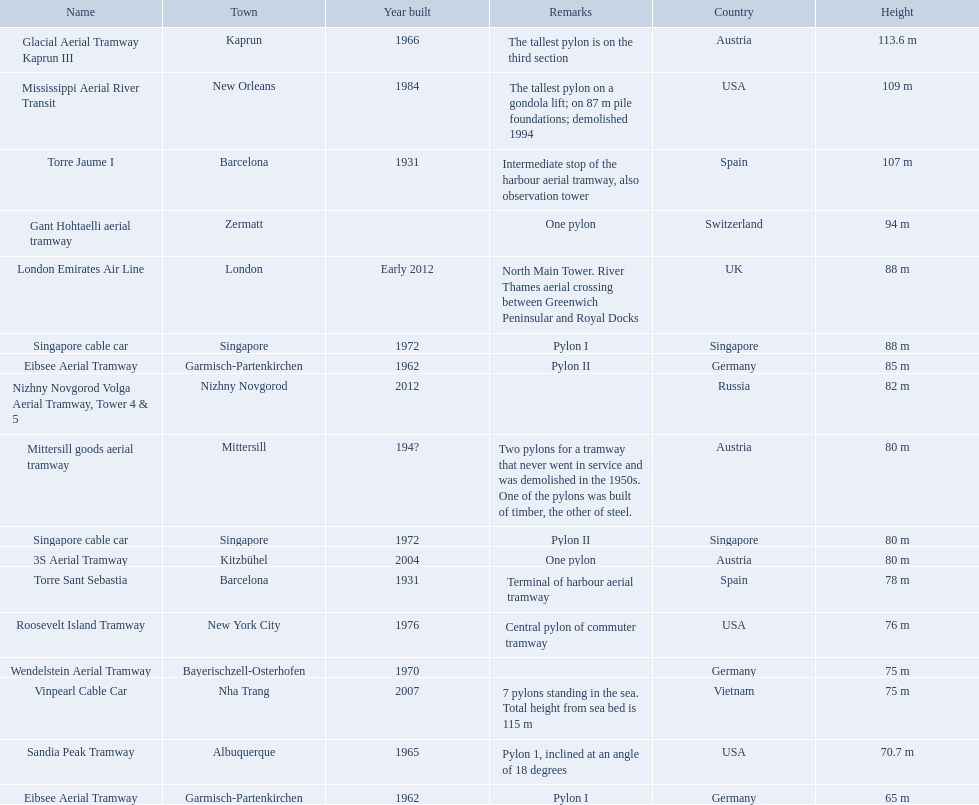Which aerial lifts are over 100 meters tall? Glacial Aerial Tramway Kaprun III, Mississippi Aerial River Transit, Torre Jaume I. Which of those was built last? Mississippi Aerial River Transit. And what is its total height? 109 m. 